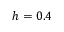Convert formula to latex. <formula><loc_0><loc_0><loc_500><loc_500>h = 0 . 4</formula> 